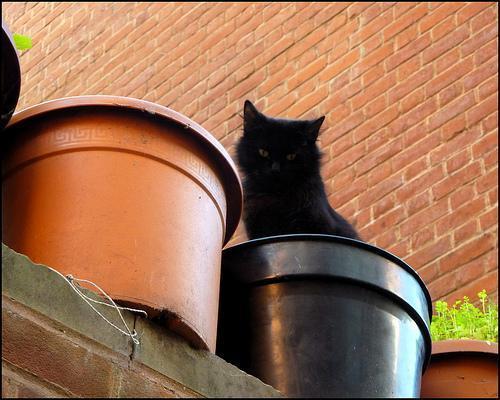How many cats are there?
Give a very brief answer. 1. 